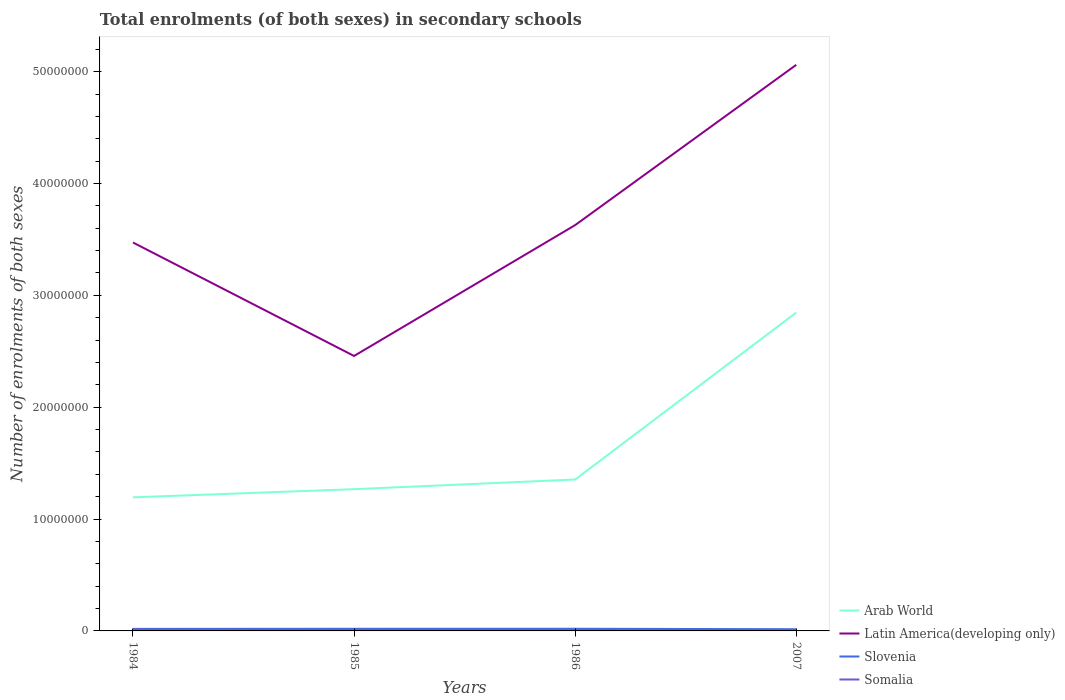How many different coloured lines are there?
Provide a short and direct response. 4. Is the number of lines equal to the number of legend labels?
Provide a short and direct response. Yes. Across all years, what is the maximum number of enrolments in secondary schools in Slovenia?
Your response must be concise. 1.53e+05. In which year was the number of enrolments in secondary schools in Latin America(developing only) maximum?
Make the answer very short. 1985. What is the total number of enrolments in secondary schools in Latin America(developing only) in the graph?
Offer a terse response. -1.43e+07. What is the difference between the highest and the second highest number of enrolments in secondary schools in Somalia?
Provide a short and direct response. 1.33e+04. How many years are there in the graph?
Keep it short and to the point. 4. What is the difference between two consecutive major ticks on the Y-axis?
Provide a short and direct response. 1.00e+07. Are the values on the major ticks of Y-axis written in scientific E-notation?
Provide a short and direct response. No. Where does the legend appear in the graph?
Your response must be concise. Bottom right. What is the title of the graph?
Your answer should be very brief. Total enrolments (of both sexes) in secondary schools. What is the label or title of the Y-axis?
Offer a very short reply. Number of enrolments of both sexes. What is the Number of enrolments of both sexes of Arab World in 1984?
Give a very brief answer. 1.19e+07. What is the Number of enrolments of both sexes in Latin America(developing only) in 1984?
Your answer should be very brief. 3.47e+07. What is the Number of enrolments of both sexes of Slovenia in 1984?
Make the answer very short. 1.81e+05. What is the Number of enrolments of both sexes in Somalia in 1984?
Make the answer very short. 1.00e+05. What is the Number of enrolments of both sexes in Arab World in 1985?
Offer a terse response. 1.27e+07. What is the Number of enrolments of both sexes of Latin America(developing only) in 1985?
Offer a terse response. 2.46e+07. What is the Number of enrolments of both sexes of Slovenia in 1985?
Your answer should be very brief. 1.92e+05. What is the Number of enrolments of both sexes of Somalia in 1985?
Your response must be concise. 9.43e+04. What is the Number of enrolments of both sexes in Arab World in 1986?
Give a very brief answer. 1.35e+07. What is the Number of enrolments of both sexes of Latin America(developing only) in 1986?
Make the answer very short. 3.63e+07. What is the Number of enrolments of both sexes of Slovenia in 1986?
Provide a succinct answer. 1.94e+05. What is the Number of enrolments of both sexes of Somalia in 1986?
Your answer should be compact. 8.85e+04. What is the Number of enrolments of both sexes of Arab World in 2007?
Keep it short and to the point. 2.85e+07. What is the Number of enrolments of both sexes in Latin America(developing only) in 2007?
Your answer should be very brief. 5.06e+07. What is the Number of enrolments of both sexes of Slovenia in 2007?
Provide a short and direct response. 1.53e+05. What is the Number of enrolments of both sexes of Somalia in 2007?
Keep it short and to the point. 8.69e+04. Across all years, what is the maximum Number of enrolments of both sexes in Arab World?
Provide a short and direct response. 2.85e+07. Across all years, what is the maximum Number of enrolments of both sexes of Latin America(developing only)?
Provide a succinct answer. 5.06e+07. Across all years, what is the maximum Number of enrolments of both sexes of Slovenia?
Make the answer very short. 1.94e+05. Across all years, what is the maximum Number of enrolments of both sexes of Somalia?
Offer a very short reply. 1.00e+05. Across all years, what is the minimum Number of enrolments of both sexes of Arab World?
Your response must be concise. 1.19e+07. Across all years, what is the minimum Number of enrolments of both sexes of Latin America(developing only)?
Your response must be concise. 2.46e+07. Across all years, what is the minimum Number of enrolments of both sexes in Slovenia?
Offer a terse response. 1.53e+05. Across all years, what is the minimum Number of enrolments of both sexes in Somalia?
Ensure brevity in your answer.  8.69e+04. What is the total Number of enrolments of both sexes of Arab World in the graph?
Offer a very short reply. 6.66e+07. What is the total Number of enrolments of both sexes of Latin America(developing only) in the graph?
Your response must be concise. 1.46e+08. What is the total Number of enrolments of both sexes in Slovenia in the graph?
Provide a succinct answer. 7.19e+05. What is the total Number of enrolments of both sexes in Somalia in the graph?
Ensure brevity in your answer.  3.70e+05. What is the difference between the Number of enrolments of both sexes of Arab World in 1984 and that in 1985?
Your answer should be very brief. -7.28e+05. What is the difference between the Number of enrolments of both sexes in Latin America(developing only) in 1984 and that in 1985?
Keep it short and to the point. 1.01e+07. What is the difference between the Number of enrolments of both sexes of Slovenia in 1984 and that in 1985?
Offer a very short reply. -1.09e+04. What is the difference between the Number of enrolments of both sexes in Somalia in 1984 and that in 1985?
Your answer should be compact. 5924. What is the difference between the Number of enrolments of both sexes in Arab World in 1984 and that in 1986?
Provide a short and direct response. -1.59e+06. What is the difference between the Number of enrolments of both sexes of Latin America(developing only) in 1984 and that in 1986?
Provide a short and direct response. -1.56e+06. What is the difference between the Number of enrolments of both sexes of Slovenia in 1984 and that in 1986?
Keep it short and to the point. -1.26e+04. What is the difference between the Number of enrolments of both sexes in Somalia in 1984 and that in 1986?
Give a very brief answer. 1.17e+04. What is the difference between the Number of enrolments of both sexes of Arab World in 1984 and that in 2007?
Your answer should be very brief. -1.65e+07. What is the difference between the Number of enrolments of both sexes of Latin America(developing only) in 1984 and that in 2007?
Ensure brevity in your answer.  -1.59e+07. What is the difference between the Number of enrolments of both sexes in Slovenia in 1984 and that in 2007?
Provide a short and direct response. 2.82e+04. What is the difference between the Number of enrolments of both sexes of Somalia in 1984 and that in 2007?
Your response must be concise. 1.33e+04. What is the difference between the Number of enrolments of both sexes in Arab World in 1985 and that in 1986?
Your answer should be compact. -8.65e+05. What is the difference between the Number of enrolments of both sexes of Latin America(developing only) in 1985 and that in 1986?
Provide a short and direct response. -1.17e+07. What is the difference between the Number of enrolments of both sexes of Slovenia in 1985 and that in 1986?
Offer a terse response. -1691. What is the difference between the Number of enrolments of both sexes in Somalia in 1985 and that in 1986?
Ensure brevity in your answer.  5804. What is the difference between the Number of enrolments of both sexes in Arab World in 1985 and that in 2007?
Your answer should be compact. -1.58e+07. What is the difference between the Number of enrolments of both sexes of Latin America(developing only) in 1985 and that in 2007?
Provide a succinct answer. -2.60e+07. What is the difference between the Number of enrolments of both sexes of Slovenia in 1985 and that in 2007?
Make the answer very short. 3.91e+04. What is the difference between the Number of enrolments of both sexes in Somalia in 1985 and that in 2007?
Your answer should be compact. 7346. What is the difference between the Number of enrolments of both sexes of Arab World in 1986 and that in 2007?
Make the answer very short. -1.49e+07. What is the difference between the Number of enrolments of both sexes in Latin America(developing only) in 1986 and that in 2007?
Ensure brevity in your answer.  -1.43e+07. What is the difference between the Number of enrolments of both sexes in Slovenia in 1986 and that in 2007?
Offer a terse response. 4.08e+04. What is the difference between the Number of enrolments of both sexes of Somalia in 1986 and that in 2007?
Provide a short and direct response. 1542. What is the difference between the Number of enrolments of both sexes of Arab World in 1984 and the Number of enrolments of both sexes of Latin America(developing only) in 1985?
Provide a succinct answer. -1.26e+07. What is the difference between the Number of enrolments of both sexes of Arab World in 1984 and the Number of enrolments of both sexes of Slovenia in 1985?
Keep it short and to the point. 1.18e+07. What is the difference between the Number of enrolments of both sexes in Arab World in 1984 and the Number of enrolments of both sexes in Somalia in 1985?
Offer a terse response. 1.19e+07. What is the difference between the Number of enrolments of both sexes in Latin America(developing only) in 1984 and the Number of enrolments of both sexes in Slovenia in 1985?
Your answer should be very brief. 3.45e+07. What is the difference between the Number of enrolments of both sexes in Latin America(developing only) in 1984 and the Number of enrolments of both sexes in Somalia in 1985?
Your answer should be compact. 3.46e+07. What is the difference between the Number of enrolments of both sexes of Slovenia in 1984 and the Number of enrolments of both sexes of Somalia in 1985?
Give a very brief answer. 8.67e+04. What is the difference between the Number of enrolments of both sexes of Arab World in 1984 and the Number of enrolments of both sexes of Latin America(developing only) in 1986?
Your response must be concise. -2.43e+07. What is the difference between the Number of enrolments of both sexes in Arab World in 1984 and the Number of enrolments of both sexes in Slovenia in 1986?
Make the answer very short. 1.18e+07. What is the difference between the Number of enrolments of both sexes in Arab World in 1984 and the Number of enrolments of both sexes in Somalia in 1986?
Your answer should be very brief. 1.19e+07. What is the difference between the Number of enrolments of both sexes in Latin America(developing only) in 1984 and the Number of enrolments of both sexes in Slovenia in 1986?
Offer a terse response. 3.45e+07. What is the difference between the Number of enrolments of both sexes in Latin America(developing only) in 1984 and the Number of enrolments of both sexes in Somalia in 1986?
Provide a short and direct response. 3.46e+07. What is the difference between the Number of enrolments of both sexes of Slovenia in 1984 and the Number of enrolments of both sexes of Somalia in 1986?
Provide a short and direct response. 9.25e+04. What is the difference between the Number of enrolments of both sexes of Arab World in 1984 and the Number of enrolments of both sexes of Latin America(developing only) in 2007?
Give a very brief answer. -3.87e+07. What is the difference between the Number of enrolments of both sexes in Arab World in 1984 and the Number of enrolments of both sexes in Slovenia in 2007?
Ensure brevity in your answer.  1.18e+07. What is the difference between the Number of enrolments of both sexes of Arab World in 1984 and the Number of enrolments of both sexes of Somalia in 2007?
Your answer should be compact. 1.19e+07. What is the difference between the Number of enrolments of both sexes in Latin America(developing only) in 1984 and the Number of enrolments of both sexes in Slovenia in 2007?
Offer a terse response. 3.46e+07. What is the difference between the Number of enrolments of both sexes of Latin America(developing only) in 1984 and the Number of enrolments of both sexes of Somalia in 2007?
Your answer should be compact. 3.46e+07. What is the difference between the Number of enrolments of both sexes in Slovenia in 1984 and the Number of enrolments of both sexes in Somalia in 2007?
Provide a succinct answer. 9.40e+04. What is the difference between the Number of enrolments of both sexes of Arab World in 1985 and the Number of enrolments of both sexes of Latin America(developing only) in 1986?
Keep it short and to the point. -2.36e+07. What is the difference between the Number of enrolments of both sexes in Arab World in 1985 and the Number of enrolments of both sexes in Slovenia in 1986?
Your answer should be very brief. 1.25e+07. What is the difference between the Number of enrolments of both sexes in Arab World in 1985 and the Number of enrolments of both sexes in Somalia in 1986?
Make the answer very short. 1.26e+07. What is the difference between the Number of enrolments of both sexes of Latin America(developing only) in 1985 and the Number of enrolments of both sexes of Slovenia in 1986?
Your answer should be compact. 2.44e+07. What is the difference between the Number of enrolments of both sexes in Latin America(developing only) in 1985 and the Number of enrolments of both sexes in Somalia in 1986?
Your answer should be compact. 2.45e+07. What is the difference between the Number of enrolments of both sexes in Slovenia in 1985 and the Number of enrolments of both sexes in Somalia in 1986?
Your answer should be very brief. 1.03e+05. What is the difference between the Number of enrolments of both sexes in Arab World in 1985 and the Number of enrolments of both sexes in Latin America(developing only) in 2007?
Keep it short and to the point. -3.79e+07. What is the difference between the Number of enrolments of both sexes of Arab World in 1985 and the Number of enrolments of both sexes of Slovenia in 2007?
Keep it short and to the point. 1.25e+07. What is the difference between the Number of enrolments of both sexes of Arab World in 1985 and the Number of enrolments of both sexes of Somalia in 2007?
Keep it short and to the point. 1.26e+07. What is the difference between the Number of enrolments of both sexes of Latin America(developing only) in 1985 and the Number of enrolments of both sexes of Slovenia in 2007?
Your response must be concise. 2.44e+07. What is the difference between the Number of enrolments of both sexes in Latin America(developing only) in 1985 and the Number of enrolments of both sexes in Somalia in 2007?
Ensure brevity in your answer.  2.45e+07. What is the difference between the Number of enrolments of both sexes in Slovenia in 1985 and the Number of enrolments of both sexes in Somalia in 2007?
Your answer should be very brief. 1.05e+05. What is the difference between the Number of enrolments of both sexes of Arab World in 1986 and the Number of enrolments of both sexes of Latin America(developing only) in 2007?
Give a very brief answer. -3.71e+07. What is the difference between the Number of enrolments of both sexes of Arab World in 1986 and the Number of enrolments of both sexes of Slovenia in 2007?
Provide a short and direct response. 1.34e+07. What is the difference between the Number of enrolments of both sexes in Arab World in 1986 and the Number of enrolments of both sexes in Somalia in 2007?
Keep it short and to the point. 1.34e+07. What is the difference between the Number of enrolments of both sexes of Latin America(developing only) in 1986 and the Number of enrolments of both sexes of Slovenia in 2007?
Keep it short and to the point. 3.61e+07. What is the difference between the Number of enrolments of both sexes of Latin America(developing only) in 1986 and the Number of enrolments of both sexes of Somalia in 2007?
Make the answer very short. 3.62e+07. What is the difference between the Number of enrolments of both sexes of Slovenia in 1986 and the Number of enrolments of both sexes of Somalia in 2007?
Provide a short and direct response. 1.07e+05. What is the average Number of enrolments of both sexes in Arab World per year?
Your answer should be very brief. 1.67e+07. What is the average Number of enrolments of both sexes in Latin America(developing only) per year?
Make the answer very short. 3.66e+07. What is the average Number of enrolments of both sexes of Slovenia per year?
Your answer should be very brief. 1.80e+05. What is the average Number of enrolments of both sexes in Somalia per year?
Offer a terse response. 9.25e+04. In the year 1984, what is the difference between the Number of enrolments of both sexes of Arab World and Number of enrolments of both sexes of Latin America(developing only)?
Your answer should be very brief. -2.28e+07. In the year 1984, what is the difference between the Number of enrolments of both sexes in Arab World and Number of enrolments of both sexes in Slovenia?
Keep it short and to the point. 1.18e+07. In the year 1984, what is the difference between the Number of enrolments of both sexes of Arab World and Number of enrolments of both sexes of Somalia?
Make the answer very short. 1.18e+07. In the year 1984, what is the difference between the Number of enrolments of both sexes of Latin America(developing only) and Number of enrolments of both sexes of Slovenia?
Keep it short and to the point. 3.45e+07. In the year 1984, what is the difference between the Number of enrolments of both sexes of Latin America(developing only) and Number of enrolments of both sexes of Somalia?
Give a very brief answer. 3.46e+07. In the year 1984, what is the difference between the Number of enrolments of both sexes of Slovenia and Number of enrolments of both sexes of Somalia?
Your response must be concise. 8.08e+04. In the year 1985, what is the difference between the Number of enrolments of both sexes in Arab World and Number of enrolments of both sexes in Latin America(developing only)?
Ensure brevity in your answer.  -1.19e+07. In the year 1985, what is the difference between the Number of enrolments of both sexes in Arab World and Number of enrolments of both sexes in Slovenia?
Ensure brevity in your answer.  1.25e+07. In the year 1985, what is the difference between the Number of enrolments of both sexes of Arab World and Number of enrolments of both sexes of Somalia?
Offer a terse response. 1.26e+07. In the year 1985, what is the difference between the Number of enrolments of both sexes of Latin America(developing only) and Number of enrolments of both sexes of Slovenia?
Your response must be concise. 2.44e+07. In the year 1985, what is the difference between the Number of enrolments of both sexes of Latin America(developing only) and Number of enrolments of both sexes of Somalia?
Give a very brief answer. 2.45e+07. In the year 1985, what is the difference between the Number of enrolments of both sexes in Slovenia and Number of enrolments of both sexes in Somalia?
Your answer should be very brief. 9.76e+04. In the year 1986, what is the difference between the Number of enrolments of both sexes in Arab World and Number of enrolments of both sexes in Latin America(developing only)?
Offer a terse response. -2.27e+07. In the year 1986, what is the difference between the Number of enrolments of both sexes of Arab World and Number of enrolments of both sexes of Slovenia?
Keep it short and to the point. 1.33e+07. In the year 1986, what is the difference between the Number of enrolments of both sexes of Arab World and Number of enrolments of both sexes of Somalia?
Provide a succinct answer. 1.34e+07. In the year 1986, what is the difference between the Number of enrolments of both sexes in Latin America(developing only) and Number of enrolments of both sexes in Slovenia?
Your response must be concise. 3.61e+07. In the year 1986, what is the difference between the Number of enrolments of both sexes in Latin America(developing only) and Number of enrolments of both sexes in Somalia?
Offer a very short reply. 3.62e+07. In the year 1986, what is the difference between the Number of enrolments of both sexes in Slovenia and Number of enrolments of both sexes in Somalia?
Make the answer very short. 1.05e+05. In the year 2007, what is the difference between the Number of enrolments of both sexes of Arab World and Number of enrolments of both sexes of Latin America(developing only)?
Keep it short and to the point. -2.21e+07. In the year 2007, what is the difference between the Number of enrolments of both sexes of Arab World and Number of enrolments of both sexes of Slovenia?
Your answer should be very brief. 2.83e+07. In the year 2007, what is the difference between the Number of enrolments of both sexes of Arab World and Number of enrolments of both sexes of Somalia?
Offer a terse response. 2.84e+07. In the year 2007, what is the difference between the Number of enrolments of both sexes of Latin America(developing only) and Number of enrolments of both sexes of Slovenia?
Your response must be concise. 5.05e+07. In the year 2007, what is the difference between the Number of enrolments of both sexes of Latin America(developing only) and Number of enrolments of both sexes of Somalia?
Make the answer very short. 5.05e+07. In the year 2007, what is the difference between the Number of enrolments of both sexes of Slovenia and Number of enrolments of both sexes of Somalia?
Give a very brief answer. 6.58e+04. What is the ratio of the Number of enrolments of both sexes in Arab World in 1984 to that in 1985?
Provide a short and direct response. 0.94. What is the ratio of the Number of enrolments of both sexes of Latin America(developing only) in 1984 to that in 1985?
Your answer should be compact. 1.41. What is the ratio of the Number of enrolments of both sexes in Slovenia in 1984 to that in 1985?
Give a very brief answer. 0.94. What is the ratio of the Number of enrolments of both sexes of Somalia in 1984 to that in 1985?
Provide a succinct answer. 1.06. What is the ratio of the Number of enrolments of both sexes of Arab World in 1984 to that in 1986?
Your answer should be compact. 0.88. What is the ratio of the Number of enrolments of both sexes of Latin America(developing only) in 1984 to that in 1986?
Make the answer very short. 0.96. What is the ratio of the Number of enrolments of both sexes in Slovenia in 1984 to that in 1986?
Give a very brief answer. 0.93. What is the ratio of the Number of enrolments of both sexes in Somalia in 1984 to that in 1986?
Your answer should be very brief. 1.13. What is the ratio of the Number of enrolments of both sexes of Arab World in 1984 to that in 2007?
Ensure brevity in your answer.  0.42. What is the ratio of the Number of enrolments of both sexes in Latin America(developing only) in 1984 to that in 2007?
Give a very brief answer. 0.69. What is the ratio of the Number of enrolments of both sexes in Slovenia in 1984 to that in 2007?
Make the answer very short. 1.18. What is the ratio of the Number of enrolments of both sexes of Somalia in 1984 to that in 2007?
Ensure brevity in your answer.  1.15. What is the ratio of the Number of enrolments of both sexes of Arab World in 1985 to that in 1986?
Your response must be concise. 0.94. What is the ratio of the Number of enrolments of both sexes in Latin America(developing only) in 1985 to that in 1986?
Offer a terse response. 0.68. What is the ratio of the Number of enrolments of both sexes in Slovenia in 1985 to that in 1986?
Your answer should be very brief. 0.99. What is the ratio of the Number of enrolments of both sexes in Somalia in 1985 to that in 1986?
Ensure brevity in your answer.  1.07. What is the ratio of the Number of enrolments of both sexes in Arab World in 1985 to that in 2007?
Offer a very short reply. 0.45. What is the ratio of the Number of enrolments of both sexes in Latin America(developing only) in 1985 to that in 2007?
Your answer should be compact. 0.49. What is the ratio of the Number of enrolments of both sexes in Slovenia in 1985 to that in 2007?
Provide a succinct answer. 1.26. What is the ratio of the Number of enrolments of both sexes in Somalia in 1985 to that in 2007?
Your answer should be compact. 1.08. What is the ratio of the Number of enrolments of both sexes of Arab World in 1986 to that in 2007?
Give a very brief answer. 0.48. What is the ratio of the Number of enrolments of both sexes of Latin America(developing only) in 1986 to that in 2007?
Your response must be concise. 0.72. What is the ratio of the Number of enrolments of both sexes of Slovenia in 1986 to that in 2007?
Provide a succinct answer. 1.27. What is the ratio of the Number of enrolments of both sexes of Somalia in 1986 to that in 2007?
Offer a very short reply. 1.02. What is the difference between the highest and the second highest Number of enrolments of both sexes of Arab World?
Your answer should be very brief. 1.49e+07. What is the difference between the highest and the second highest Number of enrolments of both sexes of Latin America(developing only)?
Your answer should be compact. 1.43e+07. What is the difference between the highest and the second highest Number of enrolments of both sexes in Slovenia?
Make the answer very short. 1691. What is the difference between the highest and the second highest Number of enrolments of both sexes of Somalia?
Offer a terse response. 5924. What is the difference between the highest and the lowest Number of enrolments of both sexes of Arab World?
Your response must be concise. 1.65e+07. What is the difference between the highest and the lowest Number of enrolments of both sexes in Latin America(developing only)?
Your answer should be very brief. 2.60e+07. What is the difference between the highest and the lowest Number of enrolments of both sexes in Slovenia?
Make the answer very short. 4.08e+04. What is the difference between the highest and the lowest Number of enrolments of both sexes in Somalia?
Provide a short and direct response. 1.33e+04. 